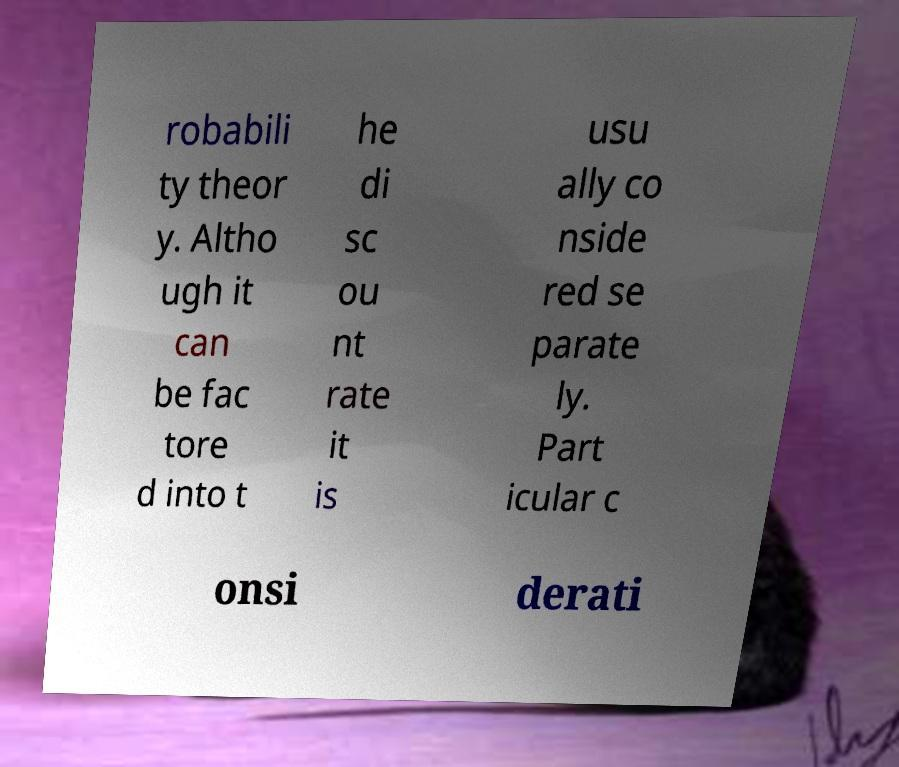There's text embedded in this image that I need extracted. Can you transcribe it verbatim? robabili ty theor y. Altho ugh it can be fac tore d into t he di sc ou nt rate it is usu ally co nside red se parate ly. Part icular c onsi derati 